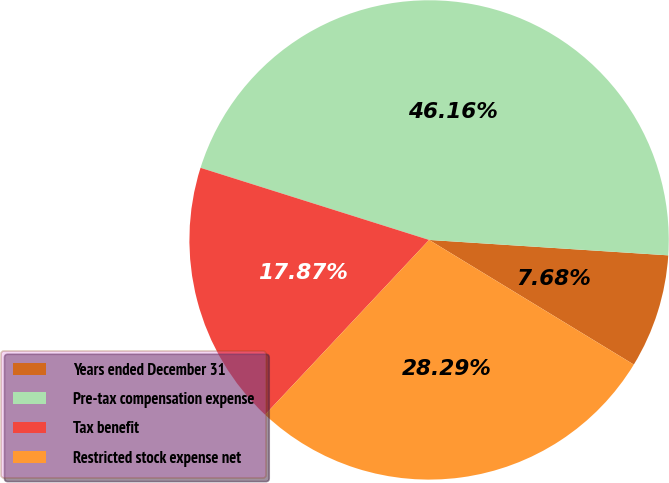Convert chart. <chart><loc_0><loc_0><loc_500><loc_500><pie_chart><fcel>Years ended December 31<fcel>Pre-tax compensation expense<fcel>Tax benefit<fcel>Restricted stock expense net<nl><fcel>7.68%<fcel>46.16%<fcel>17.87%<fcel>28.29%<nl></chart> 